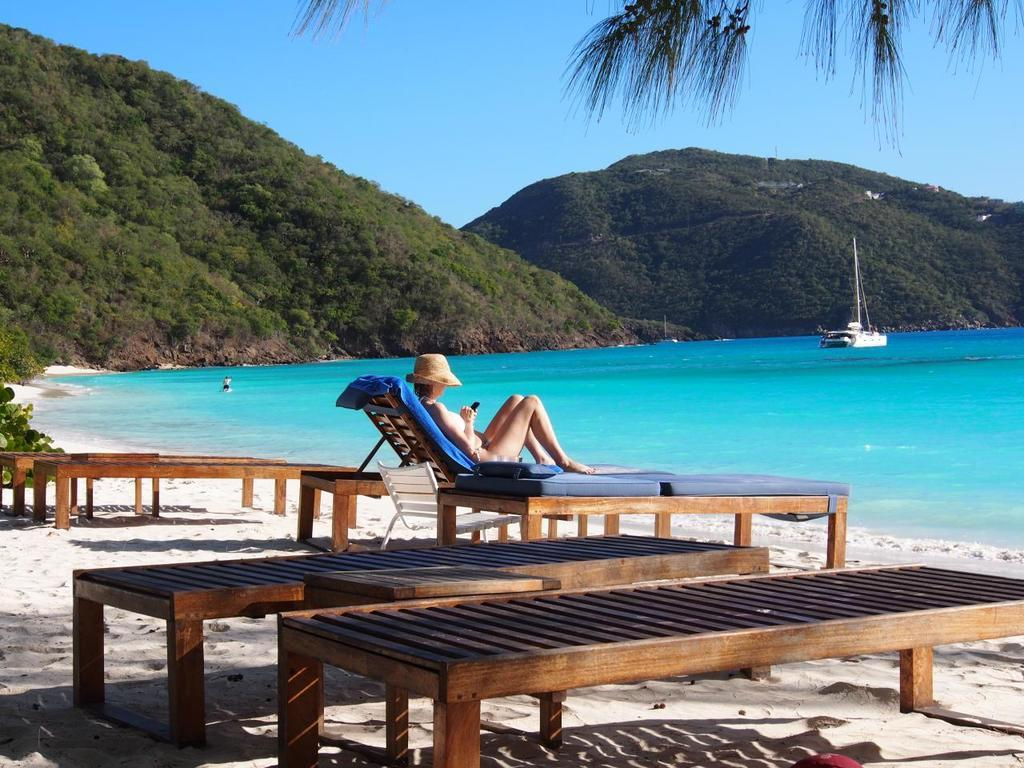What is the woman doing in the image? The woman is lying on a chair in the image. Where is the chair located? The chair is near a beach in the image. What can be seen in the water near the beach? There is a boat in the water in the image. What type of landscape is visible in the background? Mountains are visible in the image. How would you describe the weather based on the image? The sky is clear in the image, suggesting good weather. How many girls are in prison in the image? There are no girls or prison present in the image. What type of substance is the woman holding in the image? The woman is not holding any substance in the image; she is lying on a chair. 